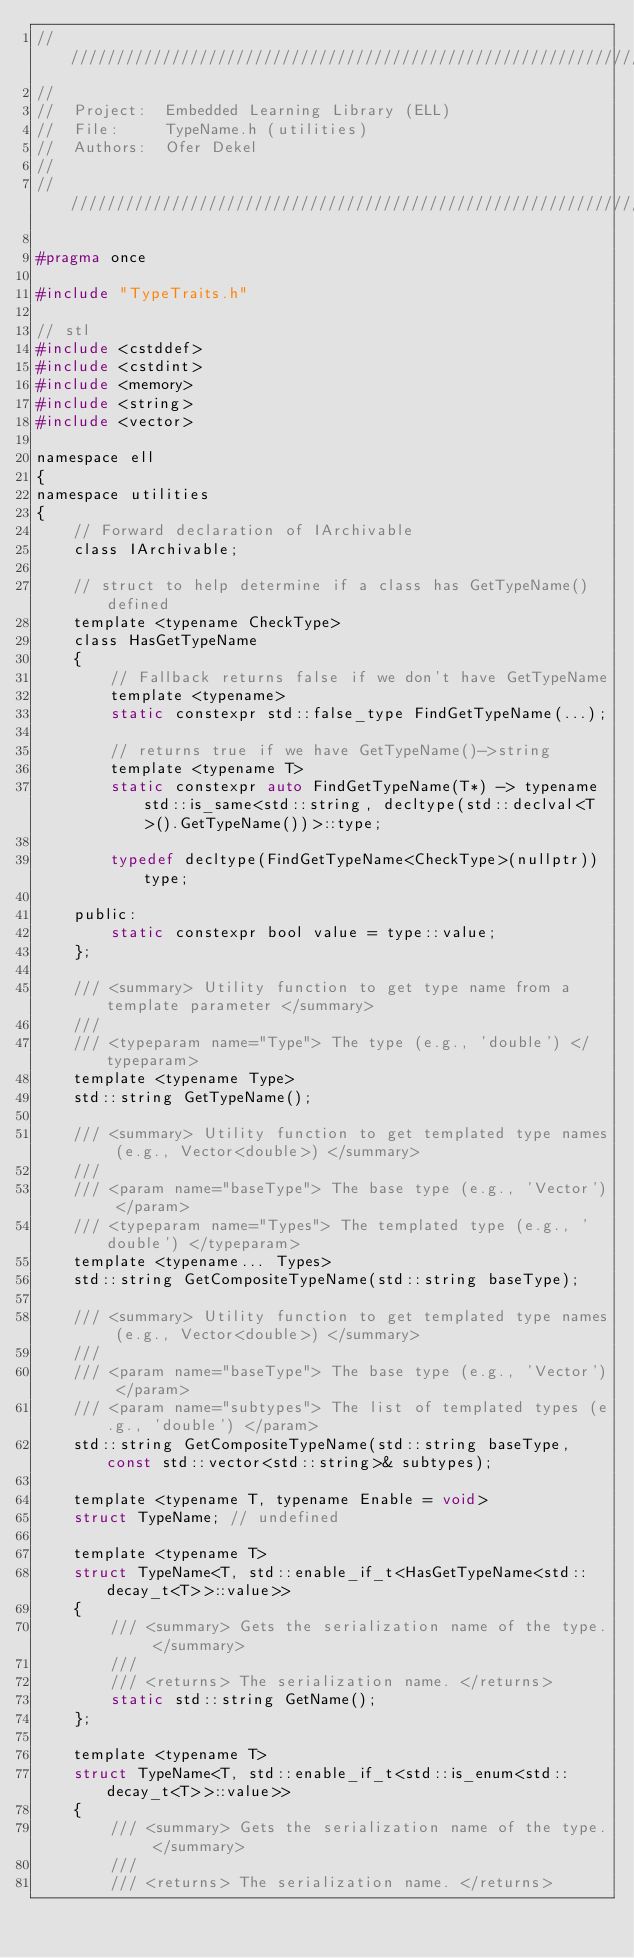<code> <loc_0><loc_0><loc_500><loc_500><_C_>////////////////////////////////////////////////////////////////////////////////////////////////////
//
//  Project:  Embedded Learning Library (ELL)
//  File:     TypeName.h (utilities)
//  Authors:  Ofer Dekel
//
////////////////////////////////////////////////////////////////////////////////////////////////////

#pragma once

#include "TypeTraits.h"

// stl
#include <cstddef>
#include <cstdint>
#include <memory>
#include <string>
#include <vector>

namespace ell
{
namespace utilities
{
    // Forward declaration of IArchivable
    class IArchivable;

    // struct to help determine if a class has GetTypeName() defined
    template <typename CheckType>
    class HasGetTypeName
    {
        // Fallback returns false if we don't have GetTypeName
        template <typename>
        static constexpr std::false_type FindGetTypeName(...);

        // returns true if we have GetTypeName()->string
        template <typename T>
        static constexpr auto FindGetTypeName(T*) -> typename std::is_same<std::string, decltype(std::declval<T>().GetTypeName())>::type;

        typedef decltype(FindGetTypeName<CheckType>(nullptr)) type;

    public:
        static constexpr bool value = type::value;
    };

    /// <summary> Utility function to get type name from a template parameter </summary>
    ///
    /// <typeparam name="Type"> The type (e.g., 'double') </typeparam>
    template <typename Type>
    std::string GetTypeName();
    
    /// <summary> Utility function to get templated type names (e.g., Vector<double>) </summary>
    ///
    /// <param name="baseType"> The base type (e.g., 'Vector') </param>
    /// <typeparam name="Types"> The templated type (e.g., 'double') </typeparam>
    template <typename... Types>
    std::string GetCompositeTypeName(std::string baseType);
    
    /// <summary> Utility function to get templated type names (e.g., Vector<double>) </summary>
    ///
    /// <param name="baseType"> The base type (e.g., 'Vector') </param>
    /// <param name="subtypes"> The list of templated types (e.g., 'double') </param>
    std::string GetCompositeTypeName(std::string baseType, const std::vector<std::string>& subtypes);

    template <typename T, typename Enable = void>
    struct TypeName; // undefined

    template <typename T>
    struct TypeName<T, std::enable_if_t<HasGetTypeName<std::decay_t<T>>::value>>
    {
        /// <summary> Gets the serialization name of the type. </summary>
        ///
        /// <returns> The serialization name. </returns>
        static std::string GetName();
    };

    template <typename T>
    struct TypeName<T, std::enable_if_t<std::is_enum<std::decay_t<T>>::value>>
    {
        /// <summary> Gets the serialization name of the type. </summary>
        ///
        /// <returns> The serialization name. </returns></code> 